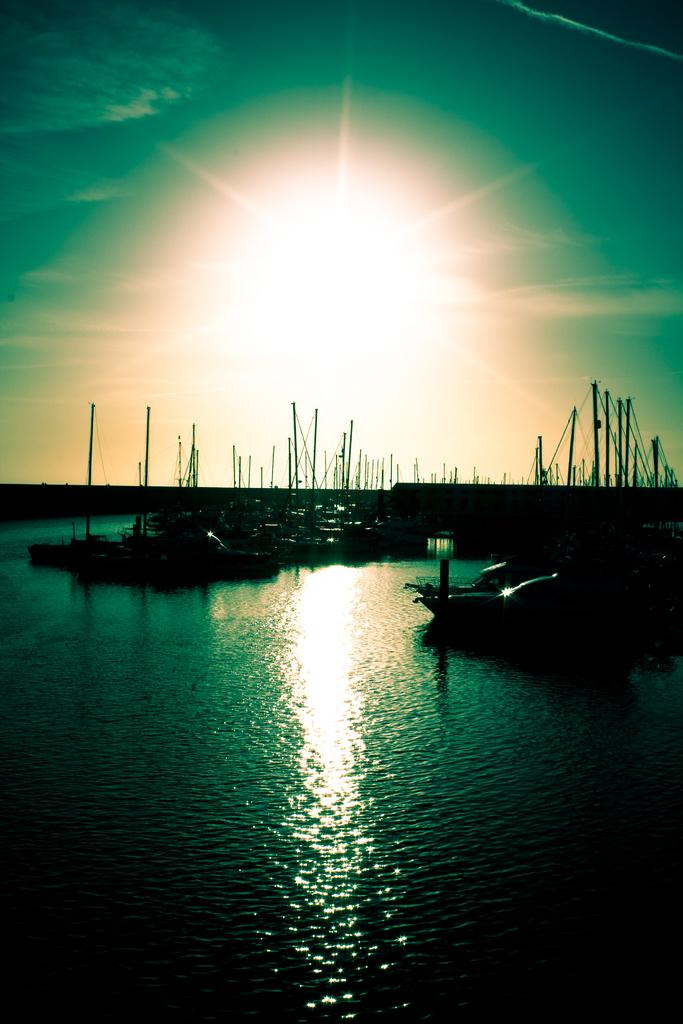What is the main subject of the image? The main subject of the image is ships. Where are the ships located? The ships are on the water. What can be seen at the top side of the image? The sun is visible at the top side of the image. What type of can is being used by the toad in the image? There is no can or toad present in the image. What word is written on the side of the ship in the image? The provided facts do not mention any words written on the side of the ship, so we cannot answer this question. 